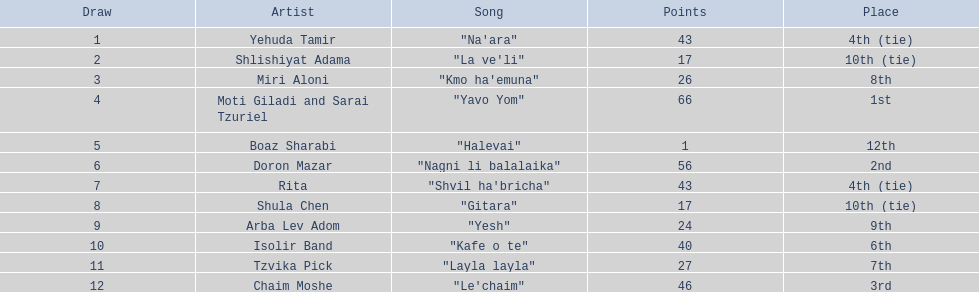What is the total amount of ties in this competition? 2. I'm looking to parse the entire table for insights. Could you assist me with that? {'header': ['Draw', 'Artist', 'Song', 'Points', 'Place'], 'rows': [['1', 'Yehuda Tamir', '"Na\'ara"', '43', '4th (tie)'], ['2', 'Shlishiyat Adama', '"La ve\'li"', '17', '10th (tie)'], ['3', 'Miri Aloni', '"Kmo ha\'emuna"', '26', '8th'], ['4', 'Moti Giladi and Sarai Tzuriel', '"Yavo Yom"', '66', '1st'], ['5', 'Boaz Sharabi', '"Halevai"', '1', '12th'], ['6', 'Doron Mazar', '"Nagni li balalaika"', '56', '2nd'], ['7', 'Rita', '"Shvil ha\'bricha"', '43', '4th (tie)'], ['8', 'Shula Chen', '"Gitara"', '17', '10th (tie)'], ['9', 'Arba Lev Adom', '"Yesh"', '24', '9th'], ['10', 'Isolir Band', '"Kafe o te"', '40', '6th'], ['11', 'Tzvika Pick', '"Layla layla"', '27', '7th'], ['12', 'Chaim Moshe', '"Le\'chaim"', '46', '3rd']]} 